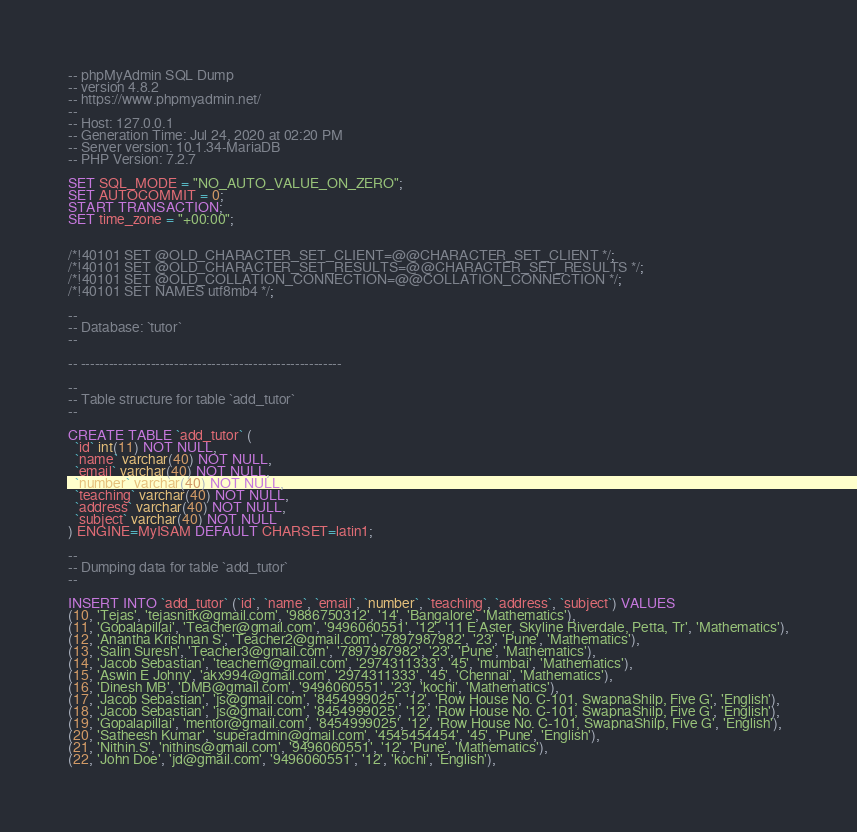Convert code to text. <code><loc_0><loc_0><loc_500><loc_500><_SQL_>-- phpMyAdmin SQL Dump
-- version 4.8.2
-- https://www.phpmyadmin.net/
--
-- Host: 127.0.0.1
-- Generation Time: Jul 24, 2020 at 02:20 PM
-- Server version: 10.1.34-MariaDB
-- PHP Version: 7.2.7

SET SQL_MODE = "NO_AUTO_VALUE_ON_ZERO";
SET AUTOCOMMIT = 0;
START TRANSACTION;
SET time_zone = "+00:00";


/*!40101 SET @OLD_CHARACTER_SET_CLIENT=@@CHARACTER_SET_CLIENT */;
/*!40101 SET @OLD_CHARACTER_SET_RESULTS=@@CHARACTER_SET_RESULTS */;
/*!40101 SET @OLD_COLLATION_CONNECTION=@@COLLATION_CONNECTION */;
/*!40101 SET NAMES utf8mb4 */;

--
-- Database: `tutor`
--

-- --------------------------------------------------------

--
-- Table structure for table `add_tutor`
--

CREATE TABLE `add_tutor` (
  `id` int(11) NOT NULL,
  `name` varchar(40) NOT NULL,
  `email` varchar(40) NOT NULL,
  `number` varchar(40) NOT NULL,
  `teaching` varchar(40) NOT NULL,
  `address` varchar(40) NOT NULL,
  `subject` varchar(40) NOT NULL
) ENGINE=MyISAM DEFAULT CHARSET=latin1;

--
-- Dumping data for table `add_tutor`
--

INSERT INTO `add_tutor` (`id`, `name`, `email`, `number`, `teaching`, `address`, `subject`) VALUES
(10, 'Tejas', 'tejasnitk@gmail.com', '9886750312', '14', 'Bangalore', 'Mathematics'),
(11, 'Gopalapillai', 'Teacher@gmail.com', '9496060551', '12', '11 E Aster, Skyline Riverdale, Petta, Tr', 'Mathematics'),
(12, 'Anantha Krishnan S', 'Teacher2@gmail.com', '7897987982', '23', 'Pune', 'Mathematics'),
(13, 'Salin Suresh', 'Teacher3@gmail.com', '7897987982', '23', 'Pune', 'Mathematics'),
(14, 'Jacob Sebastian', 'teachern@gmail.com', '2974311333', '45', 'mumbai', 'Mathematics'),
(15, 'Aswin E Johny', 'akx994@gmail.com', '2974311333', '45', 'Chennai', 'Mathematics'),
(16, 'Dinesh MB', 'DMB@gmail.com', '9496060551', '23', 'kochi', 'Mathematics'),
(17, 'Jacob Sebastian', 'js@gmail.com', '8454999025', '12', 'Row House No. C-101, SwapnaShilp, Five G', 'English'),
(18, 'Jacob Sebastian', 'js@gmail.com', '8454999025', '12', 'Row House No. C-101, SwapnaShilp, Five G', 'English'),
(19, 'Gopalapillai', 'mentor@gmail.com', '8454999025', '12', 'Row House No. C-101, SwapnaShilp, Five G', 'English'),
(20, 'Satheesh Kumar', 'superadmin@gmail.com', '4545454454', '45', 'Pune', 'English'),
(21, 'Nithin.S', 'nithins@gmail.com', '9496060551', '12', 'Pune', 'Mathematics'),
(22, 'John Doe', 'jd@gmail.com', '9496060551', '12', 'kochi', 'English'),</code> 